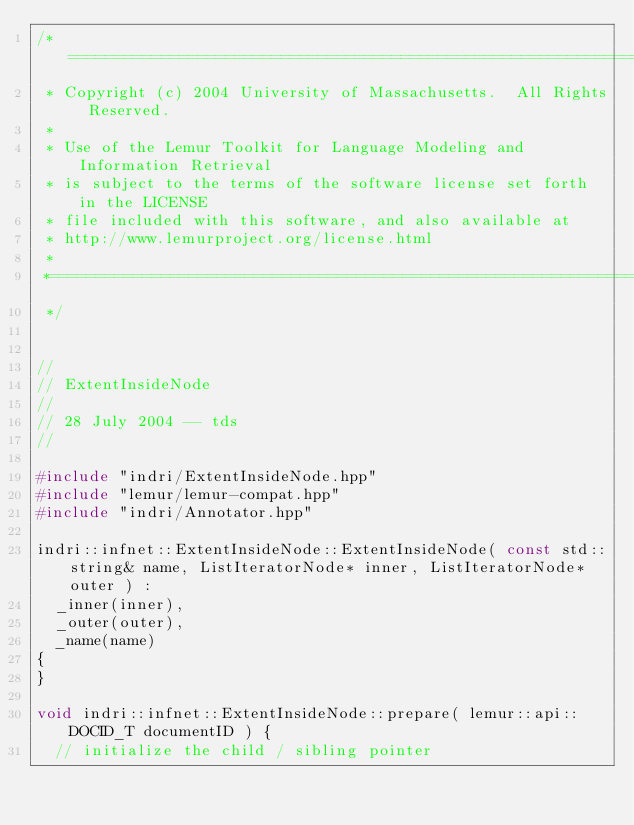<code> <loc_0><loc_0><loc_500><loc_500><_C++_>/*==========================================================================
 * Copyright (c) 2004 University of Massachusetts.  All Rights Reserved.
 *
 * Use of the Lemur Toolkit for Language Modeling and Information Retrieval
 * is subject to the terms of the software license set forth in the LICENSE
 * file included with this software, and also available at
 * http://www.lemurproject.org/license.html
 *
 *==========================================================================
 */


//
// ExtentInsideNode
//
// 28 July 2004 -- tds
//

#include "indri/ExtentInsideNode.hpp"
#include "lemur/lemur-compat.hpp"
#include "indri/Annotator.hpp"

indri::infnet::ExtentInsideNode::ExtentInsideNode( const std::string& name, ListIteratorNode* inner, ListIteratorNode* outer ) :
  _inner(inner),
  _outer(outer),
  _name(name)
{
}

void indri::infnet::ExtentInsideNode::prepare( lemur::api::DOCID_T documentID ) {
  // initialize the child / sibling pointer</code> 